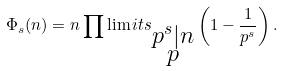Convert formula to latex. <formula><loc_0><loc_0><loc_500><loc_500>\Phi _ { s } ( n ) = n \prod \lim i t s _ { \substack { p ^ { s } | n \\ p } } \left ( 1 - \frac { 1 } { p ^ { s } } \right ) .</formula> 